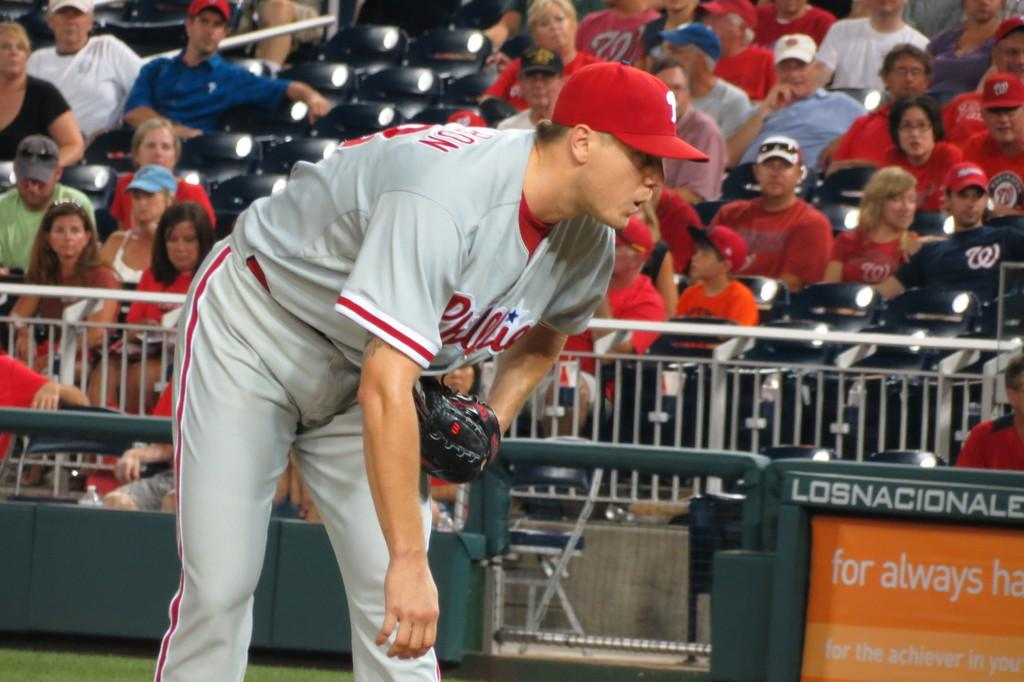<image>
Create a compact narrative representing the image presented. The player from Phillies is bending over while waiting. 